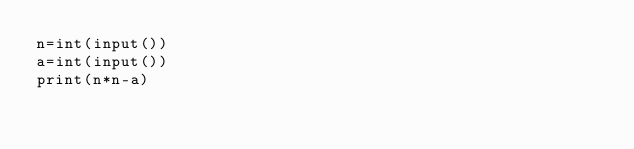<code> <loc_0><loc_0><loc_500><loc_500><_Python_>n=int(input())
a=int(input())
print(n*n-a)</code> 